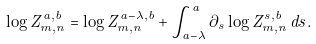Convert formula to latex. <formula><loc_0><loc_0><loc_500><loc_500>\log Z _ { m , n } ^ { a , b } = \log Z _ { m , n } ^ { a - \lambda , b } + \int _ { a - \lambda } ^ { a } \partial _ { s } \log Z _ { m , n } ^ { s , b } \, d s .</formula> 